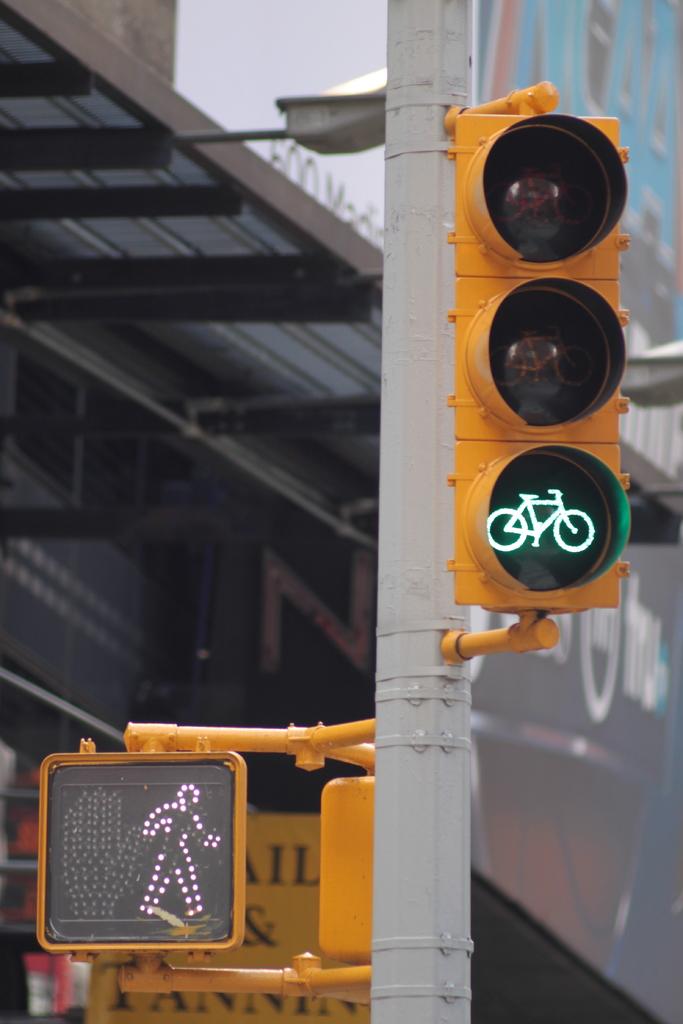What letter can you see between the walk sign and the pole?
Your response must be concise. Il. 